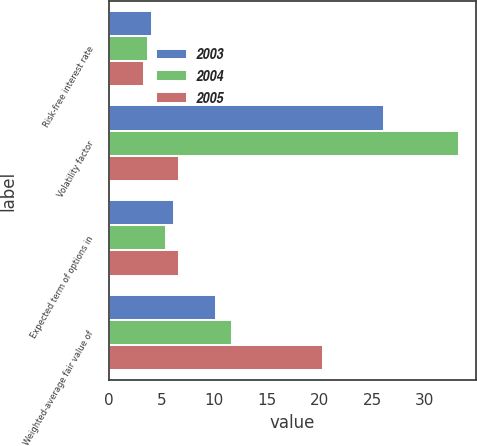Convert chart to OTSL. <chart><loc_0><loc_0><loc_500><loc_500><stacked_bar_chart><ecel><fcel>Risk-free interest rate<fcel>Volatility factor<fcel>Expected term of options in<fcel>Weighted-average fair value of<nl><fcel>2003<fcel>4.09<fcel>26.1<fcel>6.2<fcel>10.22<nl><fcel>2004<fcel>3.69<fcel>33.26<fcel>5.4<fcel>11.66<nl><fcel>2005<fcel>3.32<fcel>6.7<fcel>6.7<fcel>20.38<nl></chart> 